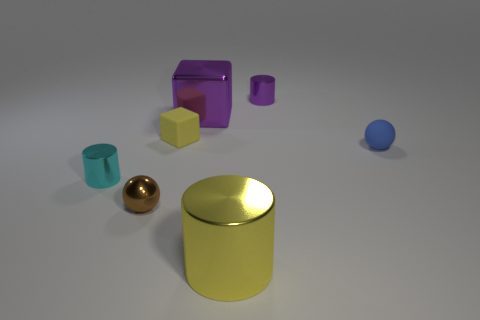There is a ball that is behind the cyan cylinder; does it have the same size as the large yellow thing?
Offer a very short reply. No. What size is the yellow object that is the same shape as the big purple metal object?
Offer a terse response. Small. Are there an equal number of tiny yellow matte things that are right of the purple block and metallic cylinders left of the small cyan shiny cylinder?
Make the answer very short. Yes. There is a cylinder that is behind the small cyan metal object; what is its size?
Your answer should be compact. Small. Do the matte cube and the large metal cylinder have the same color?
Keep it short and to the point. Yes. What material is the thing that is the same color as the big cube?
Your answer should be compact. Metal. Are there the same number of large yellow things that are behind the yellow cylinder and big purple cylinders?
Keep it short and to the point. Yes. There is a big yellow object; are there any yellow cylinders on the right side of it?
Give a very brief answer. No. Does the small brown shiny thing have the same shape as the rubber thing that is right of the purple metallic block?
Keep it short and to the point. Yes. There is a big block that is the same material as the big yellow cylinder; what is its color?
Your answer should be very brief. Purple. 